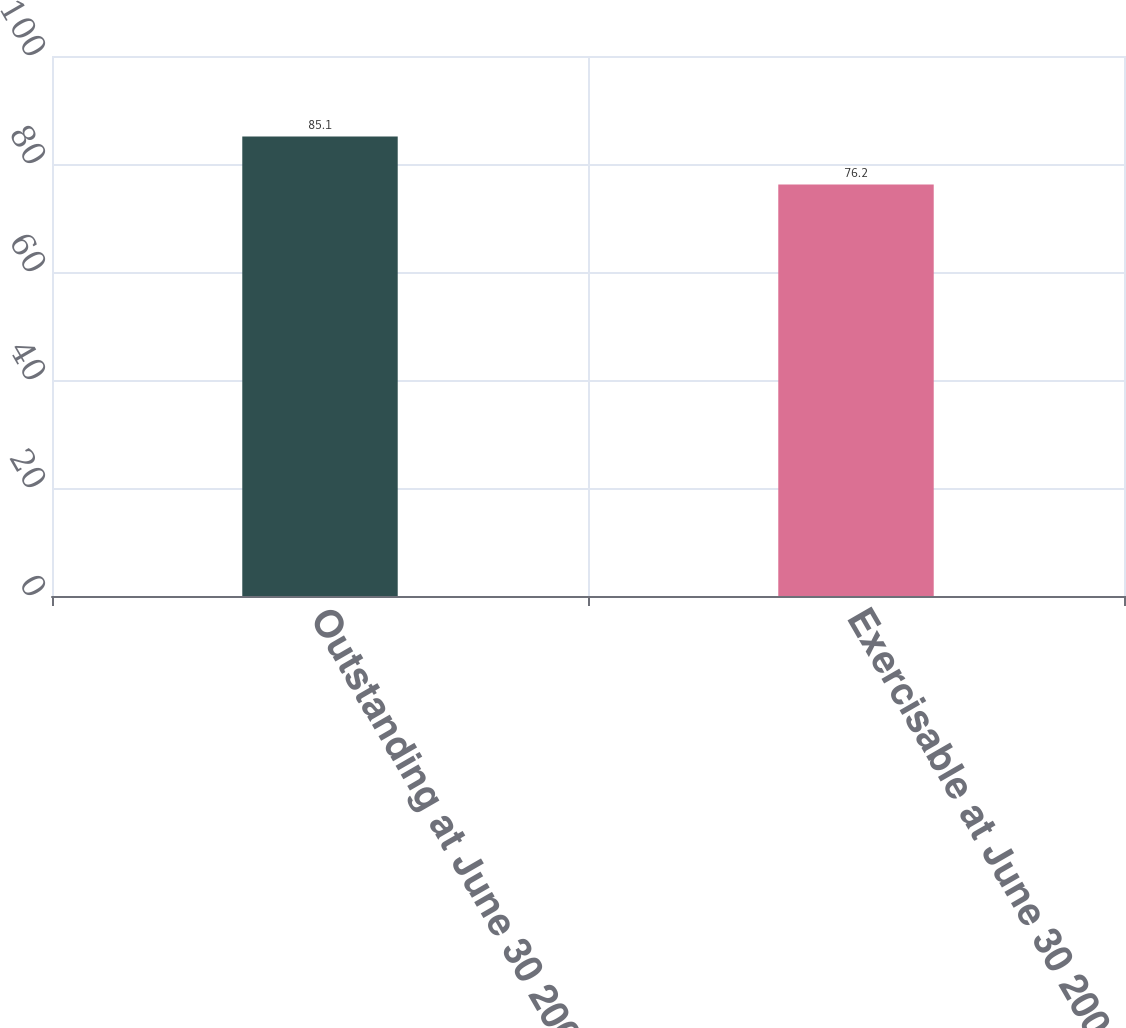Convert chart. <chart><loc_0><loc_0><loc_500><loc_500><bar_chart><fcel>Outstanding at June 30 2006<fcel>Exercisable at June 30 2006<nl><fcel>85.1<fcel>76.2<nl></chart> 